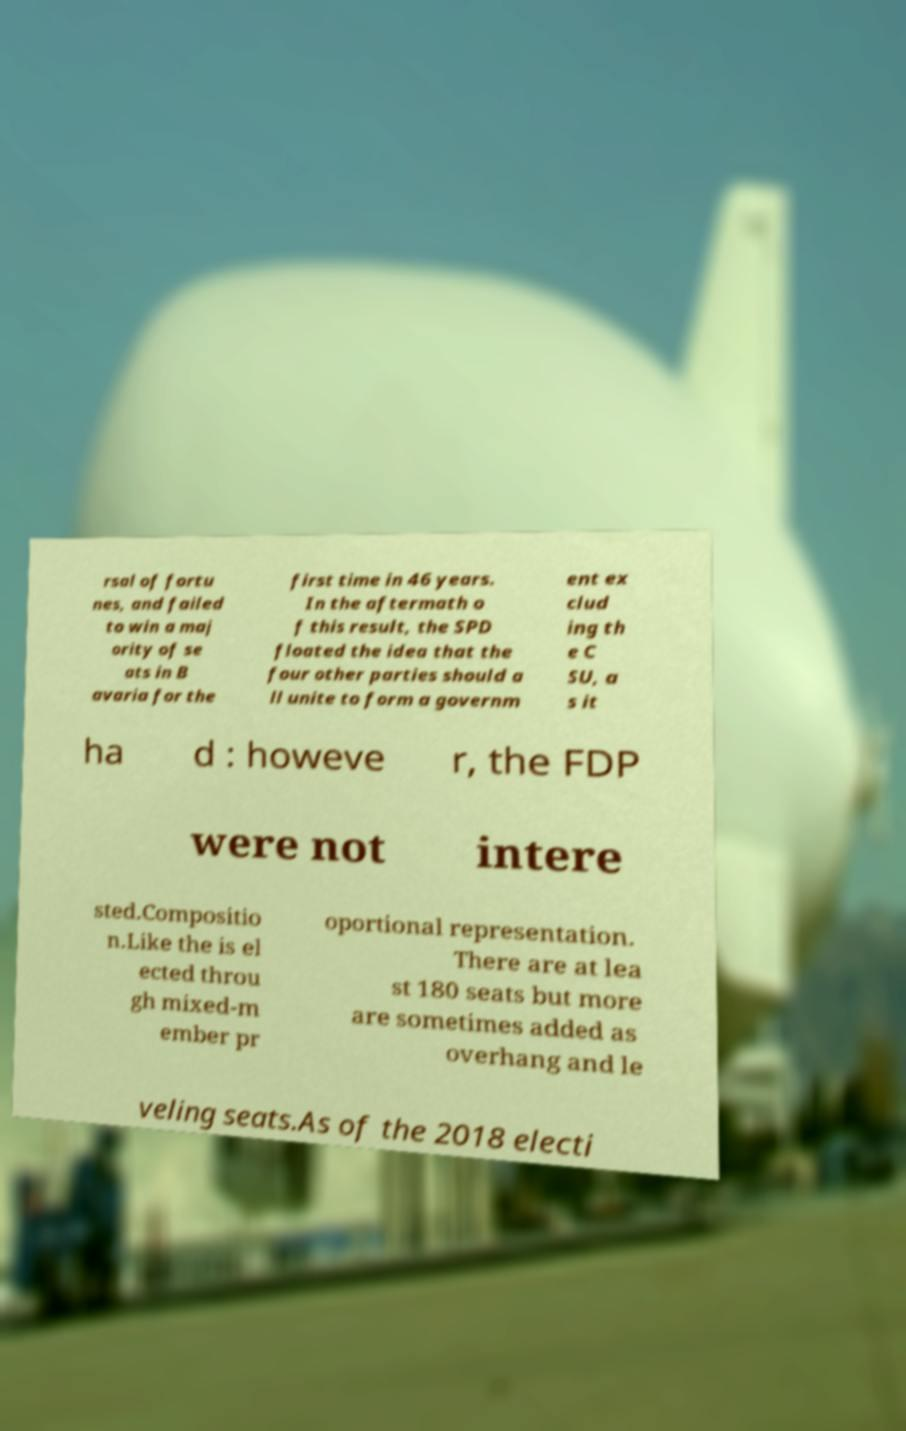For documentation purposes, I need the text within this image transcribed. Could you provide that? rsal of fortu nes, and failed to win a maj ority of se ats in B avaria for the first time in 46 years. In the aftermath o f this result, the SPD floated the idea that the four other parties should a ll unite to form a governm ent ex clud ing th e C SU, a s it ha d : howeve r, the FDP were not intere sted.Compositio n.Like the is el ected throu gh mixed-m ember pr oportional representation. There are at lea st 180 seats but more are sometimes added as overhang and le veling seats.As of the 2018 electi 